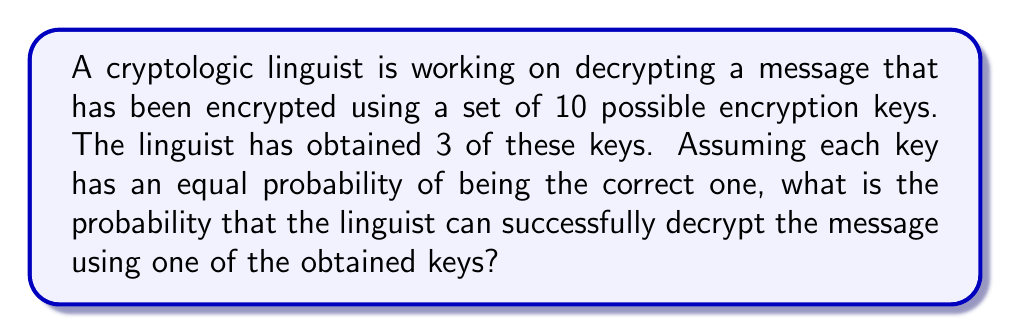Show me your answer to this math problem. Let's approach this step-by-step:

1) We have a total of 10 possible encryption keys, and the linguist has obtained 3 of them.

2) We need to find the probability that one of these 3 keys is the correct one for decrypting the message.

3) Since each key has an equal probability of being the correct one, we can use the classical definition of probability:

   $$P(\text{success}) = \frac{\text{number of favorable outcomes}}{\text{total number of possible outcomes}}$$

4) In this case:
   - The number of favorable outcomes is 3 (the number of keys the linguist has)
   - The total number of possible outcomes is 10 (the total number of keys)

5) Therefore, the probability is:

   $$P(\text{success}) = \frac{3}{10} = 0.3$$

6) We can also express this as a percentage:

   $$0.3 \times 100\% = 30\%$$

Thus, the linguist has a 30% chance of successfully decrypting the message using one of the obtained keys.
Answer: $\frac{3}{10}$ or $0.3$ or $30\%$ 